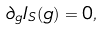<formula> <loc_0><loc_0><loc_500><loc_500>\partial _ { g } I _ { S } ( g ) = 0 ,</formula> 